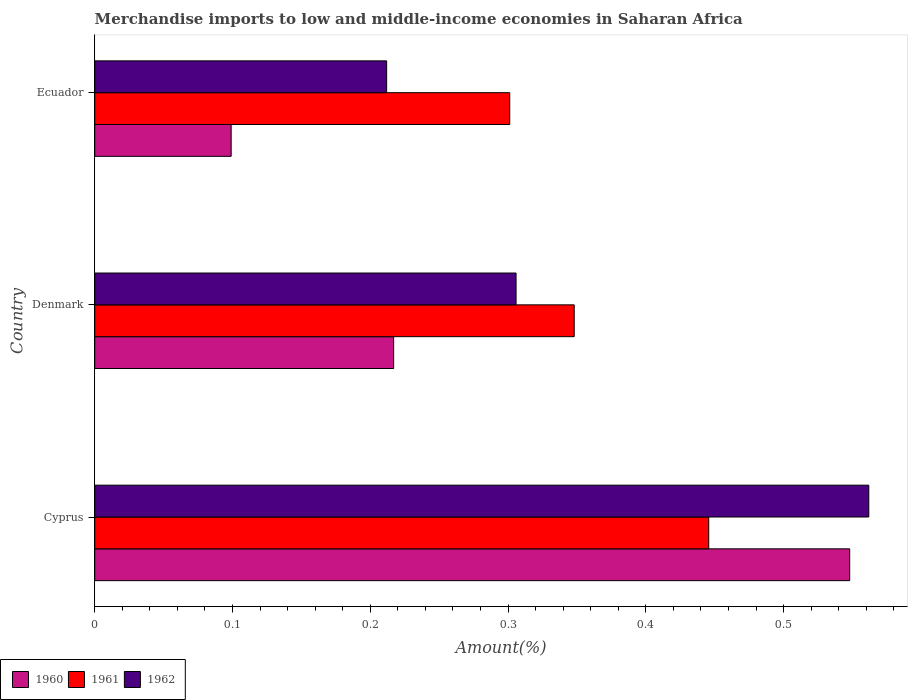How many bars are there on the 2nd tick from the top?
Ensure brevity in your answer.  3. How many bars are there on the 3rd tick from the bottom?
Provide a succinct answer. 3. What is the label of the 3rd group of bars from the top?
Make the answer very short. Cyprus. What is the percentage of amount earned from merchandise imports in 1960 in Denmark?
Offer a terse response. 0.22. Across all countries, what is the maximum percentage of amount earned from merchandise imports in 1962?
Make the answer very short. 0.56. Across all countries, what is the minimum percentage of amount earned from merchandise imports in 1961?
Your response must be concise. 0.3. In which country was the percentage of amount earned from merchandise imports in 1960 maximum?
Make the answer very short. Cyprus. In which country was the percentage of amount earned from merchandise imports in 1960 minimum?
Give a very brief answer. Ecuador. What is the total percentage of amount earned from merchandise imports in 1960 in the graph?
Keep it short and to the point. 0.86. What is the difference between the percentage of amount earned from merchandise imports in 1962 in Cyprus and that in Ecuador?
Make the answer very short. 0.35. What is the difference between the percentage of amount earned from merchandise imports in 1962 in Denmark and the percentage of amount earned from merchandise imports in 1960 in Cyprus?
Your answer should be very brief. -0.24. What is the average percentage of amount earned from merchandise imports in 1961 per country?
Make the answer very short. 0.36. What is the difference between the percentage of amount earned from merchandise imports in 1961 and percentage of amount earned from merchandise imports in 1962 in Denmark?
Your answer should be compact. 0.04. In how many countries, is the percentage of amount earned from merchandise imports in 1962 greater than 0.4 %?
Offer a terse response. 1. What is the ratio of the percentage of amount earned from merchandise imports in 1962 in Cyprus to that in Denmark?
Your response must be concise. 1.84. Is the percentage of amount earned from merchandise imports in 1962 in Denmark less than that in Ecuador?
Your response must be concise. No. Is the difference between the percentage of amount earned from merchandise imports in 1961 in Cyprus and Denmark greater than the difference between the percentage of amount earned from merchandise imports in 1962 in Cyprus and Denmark?
Your answer should be very brief. No. What is the difference between the highest and the second highest percentage of amount earned from merchandise imports in 1962?
Ensure brevity in your answer.  0.26. What is the difference between the highest and the lowest percentage of amount earned from merchandise imports in 1962?
Make the answer very short. 0.35. In how many countries, is the percentage of amount earned from merchandise imports in 1962 greater than the average percentage of amount earned from merchandise imports in 1962 taken over all countries?
Give a very brief answer. 1. What does the 2nd bar from the bottom in Denmark represents?
Make the answer very short. 1961. Is it the case that in every country, the sum of the percentage of amount earned from merchandise imports in 1962 and percentage of amount earned from merchandise imports in 1960 is greater than the percentage of amount earned from merchandise imports in 1961?
Your answer should be compact. Yes. How many bars are there?
Your answer should be very brief. 9. How many countries are there in the graph?
Your answer should be very brief. 3. What is the difference between two consecutive major ticks on the X-axis?
Ensure brevity in your answer.  0.1. Does the graph contain any zero values?
Provide a short and direct response. No. Where does the legend appear in the graph?
Ensure brevity in your answer.  Bottom left. How are the legend labels stacked?
Provide a short and direct response. Horizontal. What is the title of the graph?
Your answer should be compact. Merchandise imports to low and middle-income economies in Saharan Africa. Does "1983" appear as one of the legend labels in the graph?
Provide a short and direct response. No. What is the label or title of the X-axis?
Offer a terse response. Amount(%). What is the label or title of the Y-axis?
Your response must be concise. Country. What is the Amount(%) in 1960 in Cyprus?
Your answer should be compact. 0.55. What is the Amount(%) of 1961 in Cyprus?
Make the answer very short. 0.45. What is the Amount(%) of 1962 in Cyprus?
Your answer should be compact. 0.56. What is the Amount(%) in 1960 in Denmark?
Provide a short and direct response. 0.22. What is the Amount(%) of 1961 in Denmark?
Your answer should be very brief. 0.35. What is the Amount(%) in 1962 in Denmark?
Keep it short and to the point. 0.31. What is the Amount(%) in 1960 in Ecuador?
Make the answer very short. 0.1. What is the Amount(%) in 1961 in Ecuador?
Offer a terse response. 0.3. What is the Amount(%) in 1962 in Ecuador?
Give a very brief answer. 0.21. Across all countries, what is the maximum Amount(%) in 1960?
Provide a short and direct response. 0.55. Across all countries, what is the maximum Amount(%) of 1961?
Your answer should be compact. 0.45. Across all countries, what is the maximum Amount(%) in 1962?
Offer a terse response. 0.56. Across all countries, what is the minimum Amount(%) in 1960?
Offer a very short reply. 0.1. Across all countries, what is the minimum Amount(%) in 1961?
Ensure brevity in your answer.  0.3. Across all countries, what is the minimum Amount(%) in 1962?
Offer a terse response. 0.21. What is the total Amount(%) in 1960 in the graph?
Offer a terse response. 0.86. What is the total Amount(%) in 1961 in the graph?
Your response must be concise. 1.09. What is the total Amount(%) of 1962 in the graph?
Offer a very short reply. 1.08. What is the difference between the Amount(%) of 1960 in Cyprus and that in Denmark?
Provide a short and direct response. 0.33. What is the difference between the Amount(%) of 1961 in Cyprus and that in Denmark?
Offer a terse response. 0.1. What is the difference between the Amount(%) of 1962 in Cyprus and that in Denmark?
Make the answer very short. 0.26. What is the difference between the Amount(%) of 1960 in Cyprus and that in Ecuador?
Provide a succinct answer. 0.45. What is the difference between the Amount(%) in 1961 in Cyprus and that in Ecuador?
Keep it short and to the point. 0.14. What is the difference between the Amount(%) in 1962 in Cyprus and that in Ecuador?
Your answer should be compact. 0.35. What is the difference between the Amount(%) of 1960 in Denmark and that in Ecuador?
Offer a very short reply. 0.12. What is the difference between the Amount(%) of 1961 in Denmark and that in Ecuador?
Your response must be concise. 0.05. What is the difference between the Amount(%) in 1962 in Denmark and that in Ecuador?
Give a very brief answer. 0.09. What is the difference between the Amount(%) of 1960 in Cyprus and the Amount(%) of 1961 in Denmark?
Your answer should be very brief. 0.2. What is the difference between the Amount(%) in 1960 in Cyprus and the Amount(%) in 1962 in Denmark?
Offer a terse response. 0.24. What is the difference between the Amount(%) in 1961 in Cyprus and the Amount(%) in 1962 in Denmark?
Give a very brief answer. 0.14. What is the difference between the Amount(%) in 1960 in Cyprus and the Amount(%) in 1961 in Ecuador?
Provide a short and direct response. 0.25. What is the difference between the Amount(%) of 1960 in Cyprus and the Amount(%) of 1962 in Ecuador?
Offer a terse response. 0.34. What is the difference between the Amount(%) in 1961 in Cyprus and the Amount(%) in 1962 in Ecuador?
Provide a succinct answer. 0.23. What is the difference between the Amount(%) in 1960 in Denmark and the Amount(%) in 1961 in Ecuador?
Offer a very short reply. -0.08. What is the difference between the Amount(%) of 1960 in Denmark and the Amount(%) of 1962 in Ecuador?
Ensure brevity in your answer.  0.01. What is the difference between the Amount(%) in 1961 in Denmark and the Amount(%) in 1962 in Ecuador?
Offer a very short reply. 0.14. What is the average Amount(%) in 1960 per country?
Make the answer very short. 0.29. What is the average Amount(%) in 1961 per country?
Your answer should be compact. 0.36. What is the average Amount(%) in 1962 per country?
Give a very brief answer. 0.36. What is the difference between the Amount(%) in 1960 and Amount(%) in 1961 in Cyprus?
Your answer should be very brief. 0.1. What is the difference between the Amount(%) of 1960 and Amount(%) of 1962 in Cyprus?
Provide a succinct answer. -0.01. What is the difference between the Amount(%) in 1961 and Amount(%) in 1962 in Cyprus?
Provide a succinct answer. -0.12. What is the difference between the Amount(%) in 1960 and Amount(%) in 1961 in Denmark?
Keep it short and to the point. -0.13. What is the difference between the Amount(%) in 1960 and Amount(%) in 1962 in Denmark?
Your response must be concise. -0.09. What is the difference between the Amount(%) in 1961 and Amount(%) in 1962 in Denmark?
Offer a very short reply. 0.04. What is the difference between the Amount(%) of 1960 and Amount(%) of 1961 in Ecuador?
Offer a terse response. -0.2. What is the difference between the Amount(%) in 1960 and Amount(%) in 1962 in Ecuador?
Give a very brief answer. -0.11. What is the difference between the Amount(%) in 1961 and Amount(%) in 1962 in Ecuador?
Offer a terse response. 0.09. What is the ratio of the Amount(%) of 1960 in Cyprus to that in Denmark?
Offer a very short reply. 2.53. What is the ratio of the Amount(%) in 1961 in Cyprus to that in Denmark?
Provide a succinct answer. 1.28. What is the ratio of the Amount(%) in 1962 in Cyprus to that in Denmark?
Keep it short and to the point. 1.84. What is the ratio of the Amount(%) in 1960 in Cyprus to that in Ecuador?
Give a very brief answer. 5.53. What is the ratio of the Amount(%) of 1961 in Cyprus to that in Ecuador?
Provide a succinct answer. 1.48. What is the ratio of the Amount(%) in 1962 in Cyprus to that in Ecuador?
Offer a terse response. 2.65. What is the ratio of the Amount(%) in 1960 in Denmark to that in Ecuador?
Offer a very short reply. 2.19. What is the ratio of the Amount(%) of 1961 in Denmark to that in Ecuador?
Offer a very short reply. 1.16. What is the ratio of the Amount(%) in 1962 in Denmark to that in Ecuador?
Your answer should be very brief. 1.44. What is the difference between the highest and the second highest Amount(%) in 1960?
Offer a very short reply. 0.33. What is the difference between the highest and the second highest Amount(%) in 1961?
Offer a terse response. 0.1. What is the difference between the highest and the second highest Amount(%) in 1962?
Offer a very short reply. 0.26. What is the difference between the highest and the lowest Amount(%) of 1960?
Your answer should be compact. 0.45. What is the difference between the highest and the lowest Amount(%) in 1961?
Keep it short and to the point. 0.14. What is the difference between the highest and the lowest Amount(%) of 1962?
Your response must be concise. 0.35. 